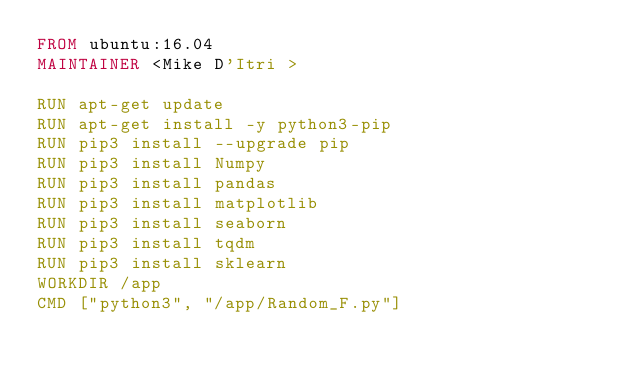Convert code to text. <code><loc_0><loc_0><loc_500><loc_500><_Dockerfile_>FROM ubuntu:16.04
MAINTAINER <Mike D'Itri >

RUN apt-get update
RUN apt-get install -y python3-pip
RUN pip3 install --upgrade pip
RUN pip3 install Numpy
RUN pip3 install pandas 
RUN pip3 install matplotlib
RUN pip3 install seaborn
RUN pip3 install tqdm
RUN pip3 install sklearn
WORKDIR /app
CMD ["python3", "/app/Random_F.py"]</code> 